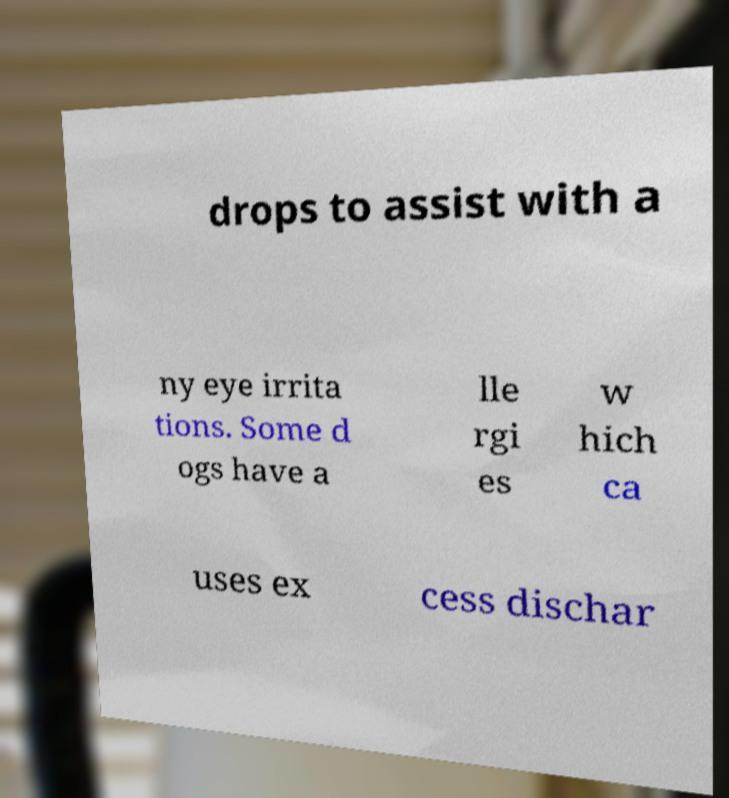Could you assist in decoding the text presented in this image and type it out clearly? drops to assist with a ny eye irrita tions. Some d ogs have a lle rgi es w hich ca uses ex cess dischar 